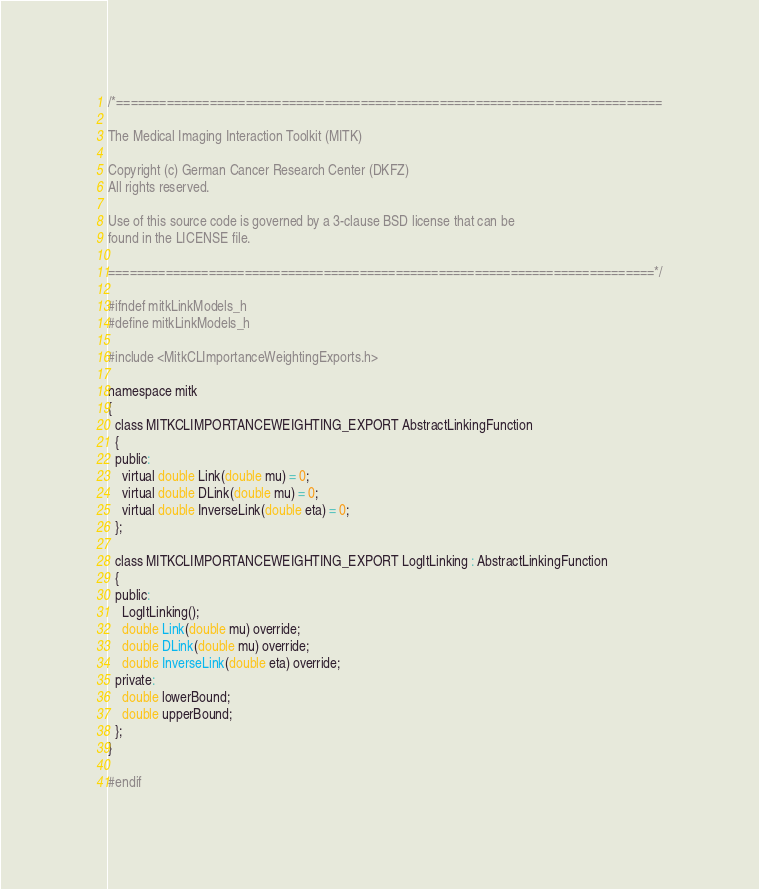Convert code to text. <code><loc_0><loc_0><loc_500><loc_500><_C_>/*============================================================================

The Medical Imaging Interaction Toolkit (MITK)

Copyright (c) German Cancer Research Center (DKFZ)
All rights reserved.

Use of this source code is governed by a 3-clause BSD license that can be
found in the LICENSE file.

============================================================================*/

#ifndef mitkLinkModels_h
#define mitkLinkModels_h

#include <MitkCLImportanceWeightingExports.h>

namespace mitk
{
  class MITKCLIMPORTANCEWEIGHTING_EXPORT AbstractLinkingFunction
  {
  public:
    virtual double Link(double mu) = 0;
    virtual double DLink(double mu) = 0;
    virtual double InverseLink(double eta) = 0;
  };

  class MITKCLIMPORTANCEWEIGHTING_EXPORT LogItLinking : AbstractLinkingFunction
  {
  public:
    LogItLinking();
    double Link(double mu) override;
    double DLink(double mu) override;
    double InverseLink(double eta) override;
  private:
    double lowerBound;
    double upperBound;
  };
}

#endif
</code> 